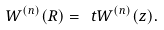<formula> <loc_0><loc_0><loc_500><loc_500>W ^ { ( n ) } ( R ) = \ t W ^ { ( n ) } ( z ) .</formula> 